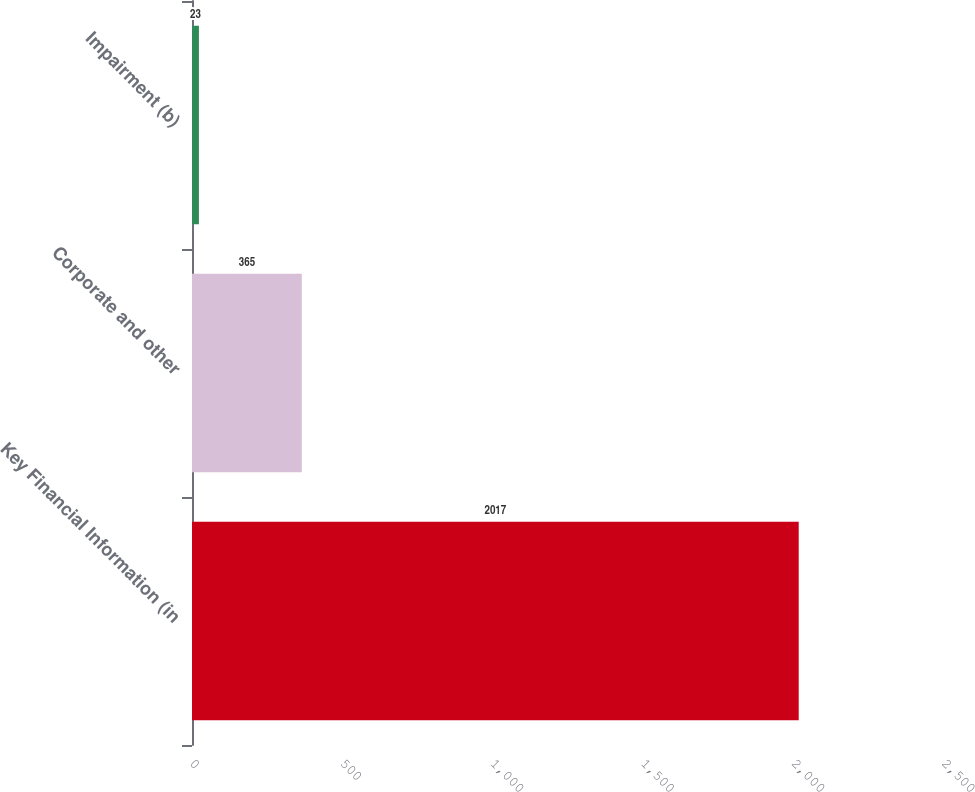Convert chart. <chart><loc_0><loc_0><loc_500><loc_500><bar_chart><fcel>Key Financial Information (in<fcel>Corporate and other<fcel>Impairment (b)<nl><fcel>2017<fcel>365<fcel>23<nl></chart> 